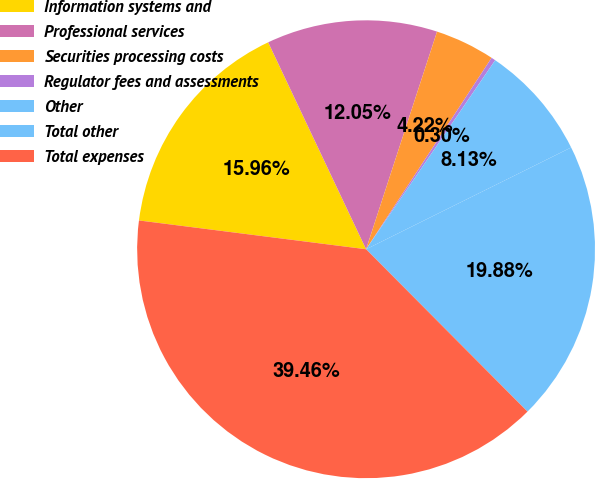<chart> <loc_0><loc_0><loc_500><loc_500><pie_chart><fcel>Information systems and<fcel>Professional services<fcel>Securities processing costs<fcel>Regulator fees and assessments<fcel>Other<fcel>Total other<fcel>Total expenses<nl><fcel>15.96%<fcel>12.05%<fcel>4.22%<fcel>0.3%<fcel>8.13%<fcel>19.88%<fcel>39.46%<nl></chart> 